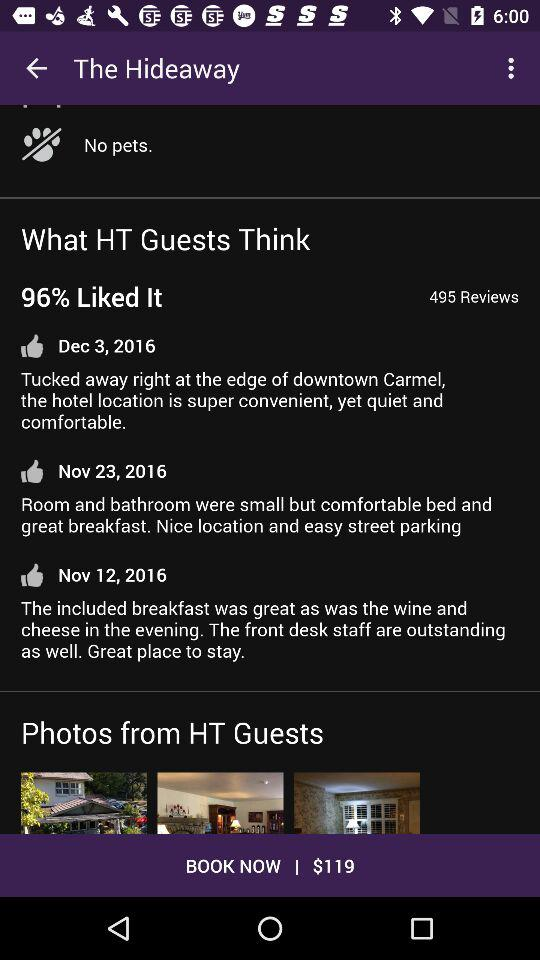How many photos are there of the hotel?
Answer the question using a single word or phrase. 3 